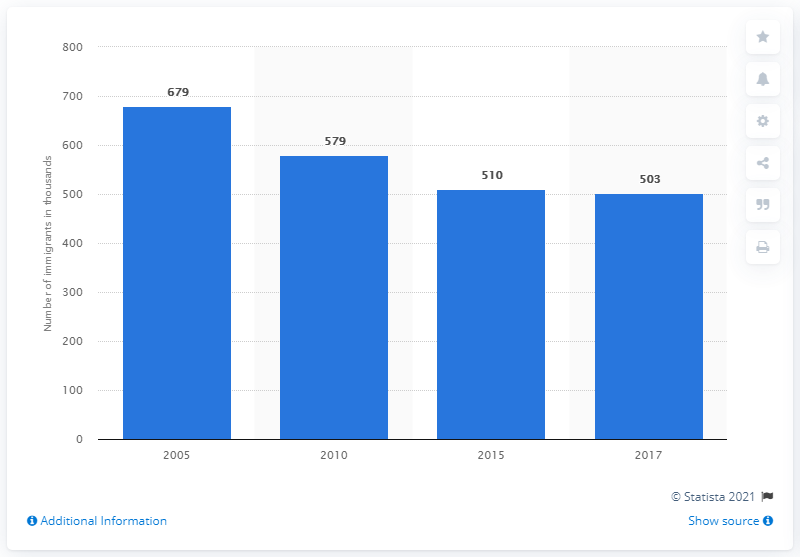Identify some key points in this picture. In 2010, approximately 579 immigrants lived in Nepal. 